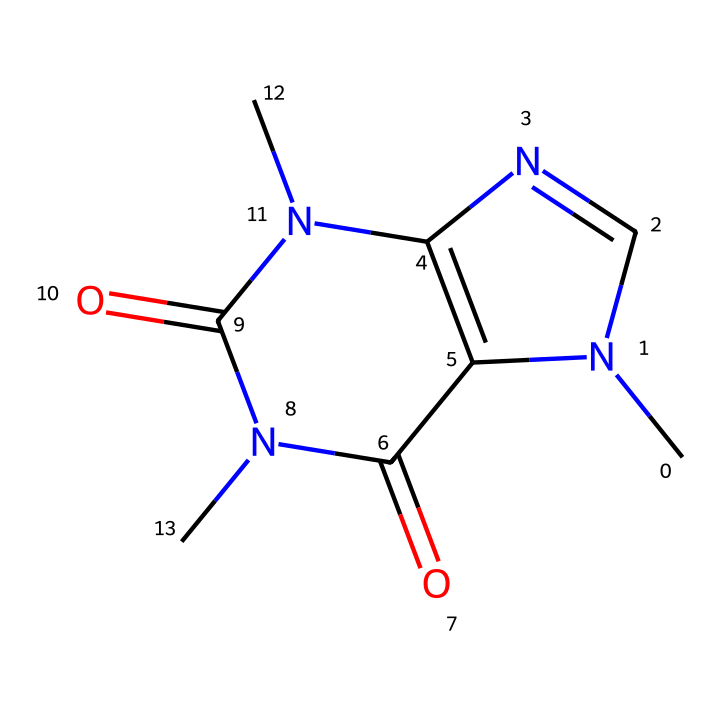What is the primary type of atoms present in caffeine? Analyzing the SMILES representation, we can see a variety of elements, but the predominant types are carbon (C), nitrogen (N), and oxygen (O). There are no sulfur atoms in this chemical, making carbon, nitrogen, and oxygen the primary types.
Answer: carbon, nitrogen, oxygen How many nitrogen atoms are present in caffeine? By examining the structure, we identify the total number of nitrogen atoms. The SMILES notation shows that there are three occurrences of 'N', indicating the presence of three nitrogen atoms in the molecule.
Answer: three What is the relation between nitrogen atoms and the caffeine's psychoactive properties? Caffeine contains nitrogen atoms that are part of its structure. This aligns with the properties of alkaloids, which often contain nitrogen and contribute to psychoactive effects. Therefore, the nitrogen plays a crucial role in those effects.
Answer: psychoactive How many carbon atoms are in the molecular structure of caffeine? Counting the 'C' symbols in the SMILES notation reveals the total number of carbon atoms present in caffeine. There are eight 'C' instances, indicating there are eight carbon atoms in the structure.
Answer: eight Does caffeine contain any sulfur atoms in its structure? Review of the SMILES code shows it only contains carbon, nitrogen, and oxygen, without any 'S' symbols that would indicate sulfur atoms. Therefore, caffeine does not have sulfur in its molecular design.
Answer: no How many rings are present in the caffeine structure? Inspecting the SMILES representation suggests the presence of multiple cycles. The notation given shows that there are two fused rings, which is characteristic of the caffeine's bicyclic structure.
Answer: two Is caffeine an organosulfur compound? By definition, organosulfur compounds specifically contain sulfur. Since the structural analysis shows no sulfur atom present in caffeine, it cannot be classified as an organosulfur compound.
Answer: no 